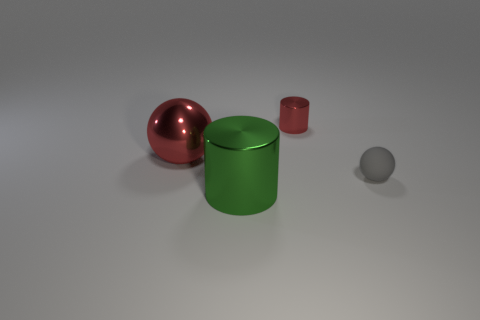Subtract all green cylinders. How many cylinders are left? 1 Subtract 1 cylinders. How many cylinders are left? 1 Subtract all blue spheres. Subtract all purple cylinders. How many spheres are left? 2 Subtract all brown blocks. How many blue balls are left? 0 Subtract all small gray things. Subtract all red objects. How many objects are left? 1 Add 4 small rubber objects. How many small rubber objects are left? 5 Add 3 big green objects. How many big green objects exist? 4 Add 3 large yellow rubber cubes. How many objects exist? 7 Subtract 0 blue cylinders. How many objects are left? 4 